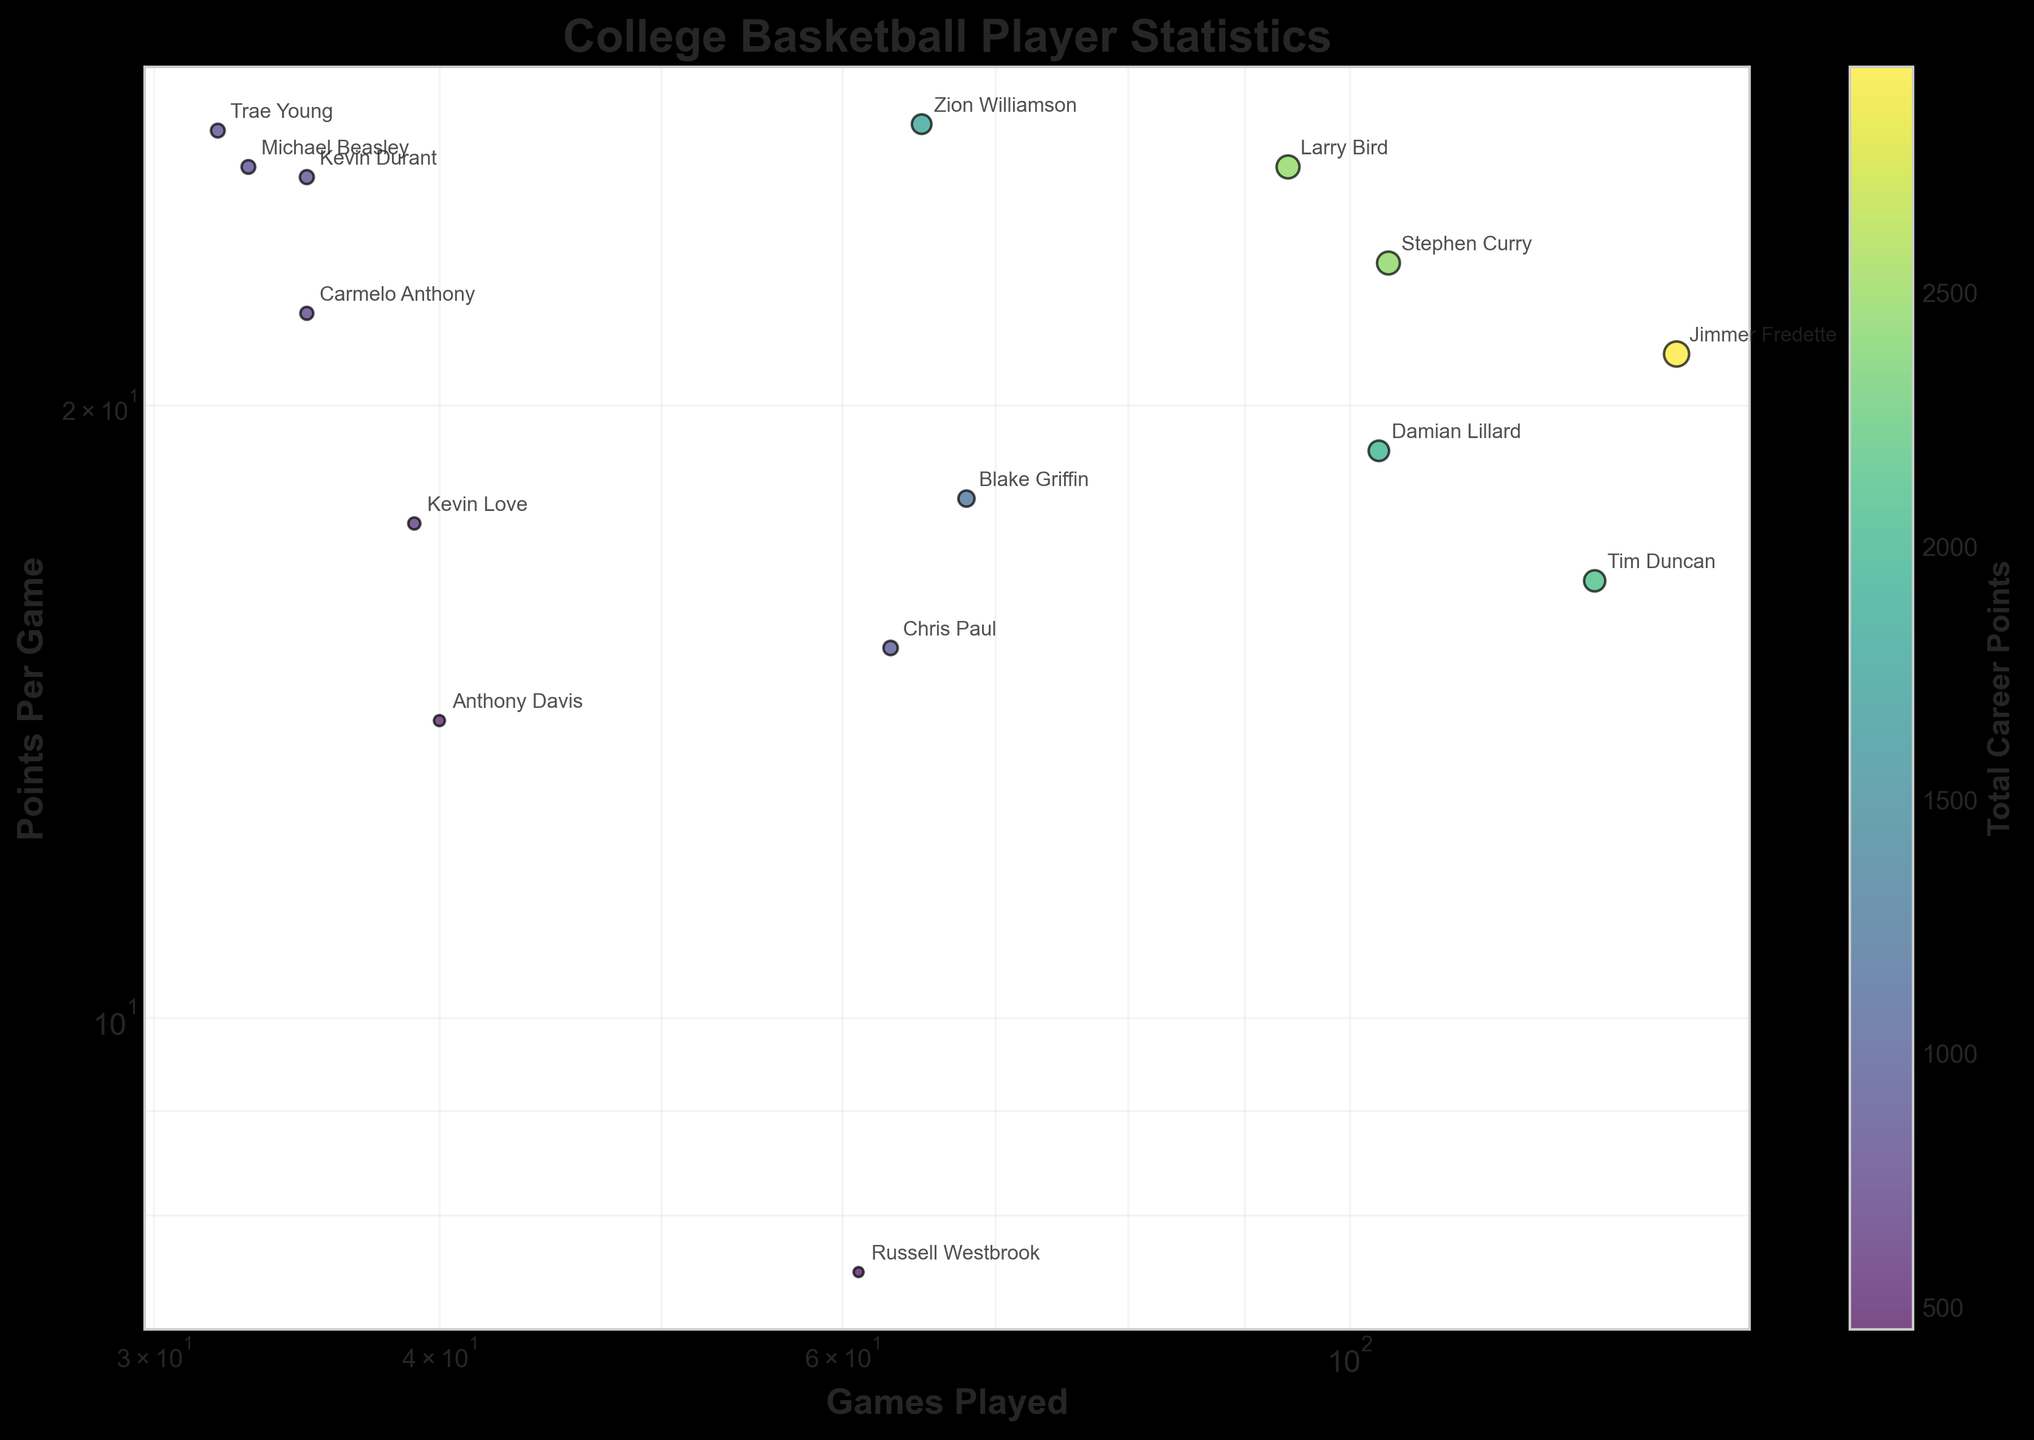What's the title of the figure? The title of the figure is located at the top, set in a bold font. It provides a summary of what the plot is about.
Answer: College Basketball Player Statistics How many players are represented in the plot? By counting the data points on the scatter plot, labeled with player names.
Answer: 15 Which player has the highest scoring average? Locate the data point furthest up the y-axis (Points Per Game) and identify the associated player label.
Answer: Zion Williamson Which player played the fewest games while maintaining a high scoring average? Look for the player data point with the lowest value on the x-axis (Games Played) but a high value on the y-axis (Points Per Game), then check the player name.
Answer: Trae Young Compare the Points Per Game of Larry Bird and Michael Beasley. Who scored more on average? Find both players on the scatter plot, then compare their y-axis values (Points Per Game).
Answer: Larry Bird Between Stephen Curry and Damian Lillard, who played more games? Locate both players on the scatter plot and compare their x-axis values (Games Played).
Answer: Stephen Curry Which player has the most total career points? The color and size of the markers indicate total career points. Find the most prominent data point and check the player name.
Answer: Jimmer Fredette How is the total career points conveyed in the plot? The total career points are reflected by both the color and size of the data points, with a color scale indicating higher points numerically.
Answer: Color and size of the data points What is the range of games played among the players in this plot? Identify the smallest and largest x-axis values corresponding to the figure's data points.
Answer: 32 to 139 Are there any players with both low total career points and low games played? Look for data points with small sizes (indicating low total career points) and low x-axis values (indicating fewer games played).
Answer: Russell Westbrook 